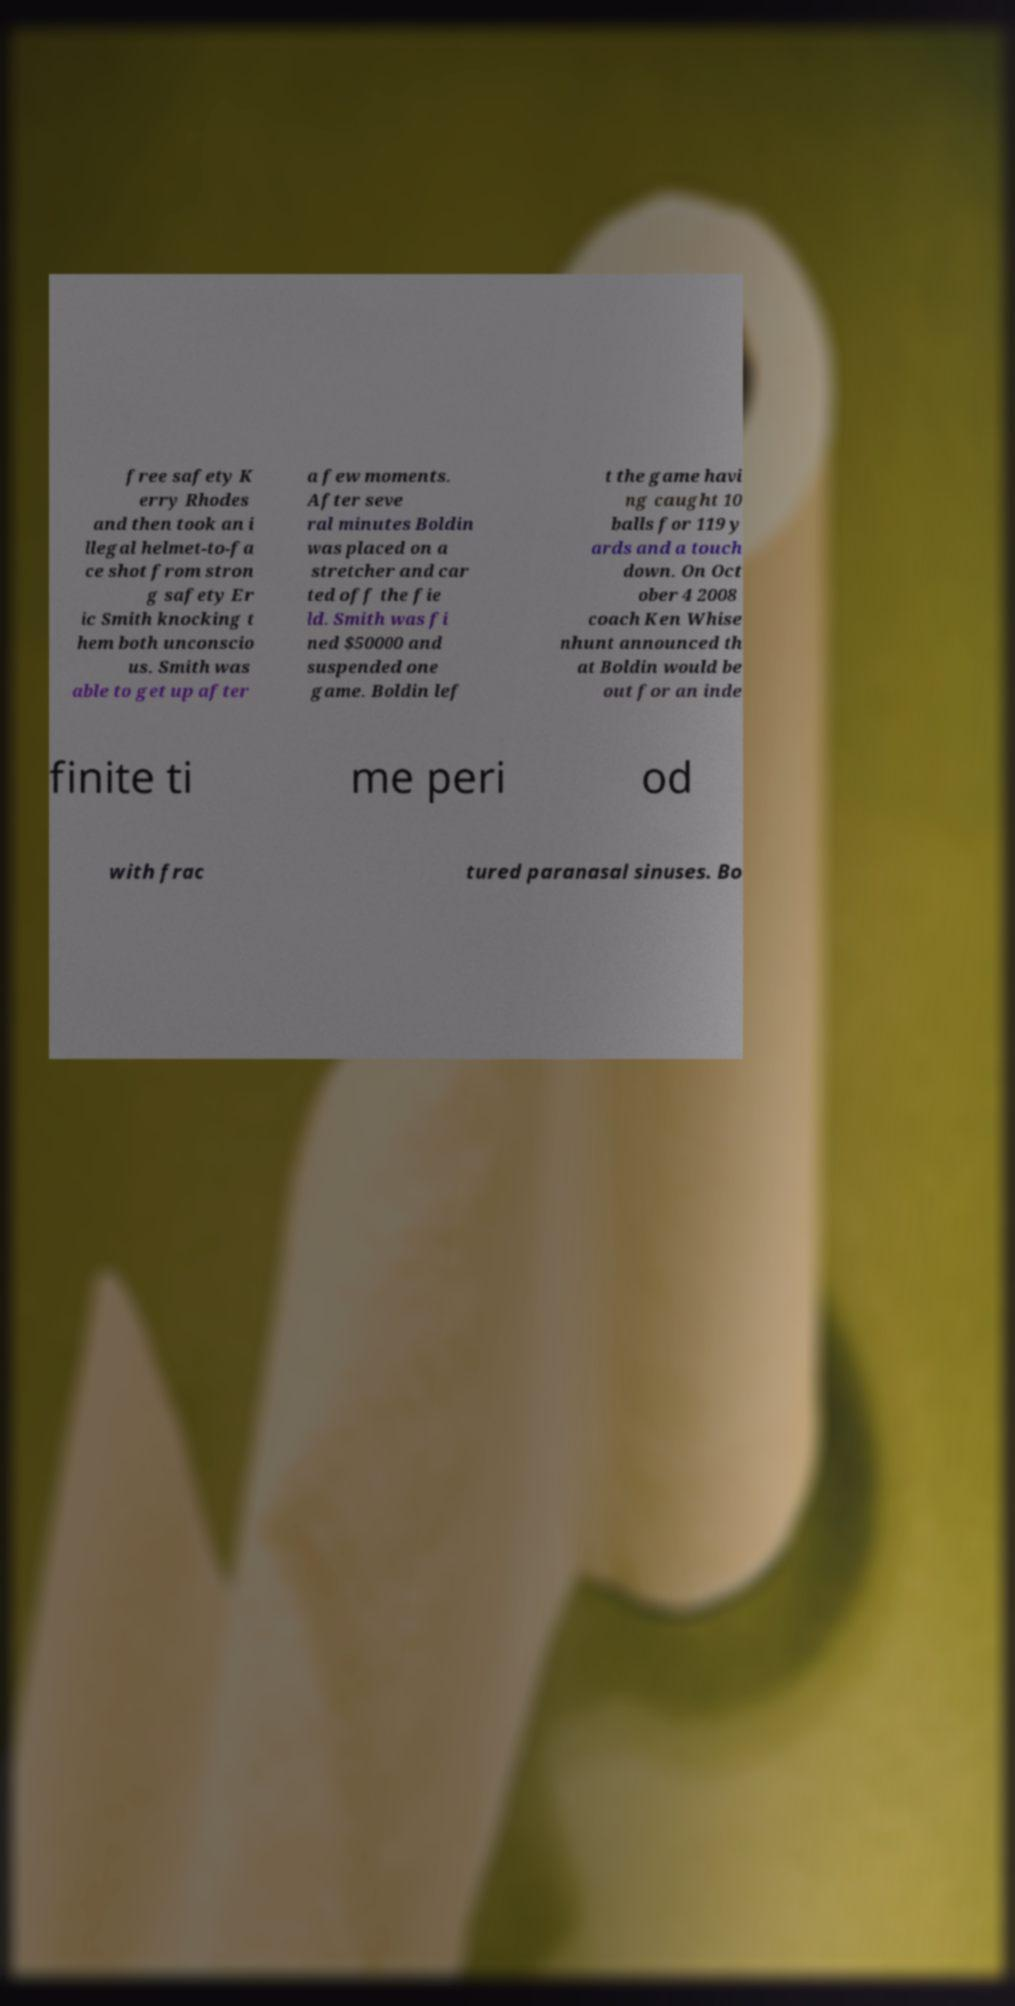What messages or text are displayed in this image? I need them in a readable, typed format. free safety K erry Rhodes and then took an i llegal helmet-to-fa ce shot from stron g safety Er ic Smith knocking t hem both unconscio us. Smith was able to get up after a few moments. After seve ral minutes Boldin was placed on a stretcher and car ted off the fie ld. Smith was fi ned $50000 and suspended one game. Boldin lef t the game havi ng caught 10 balls for 119 y ards and a touch down. On Oct ober 4 2008 coach Ken Whise nhunt announced th at Boldin would be out for an inde finite ti me peri od with frac tured paranasal sinuses. Bo 